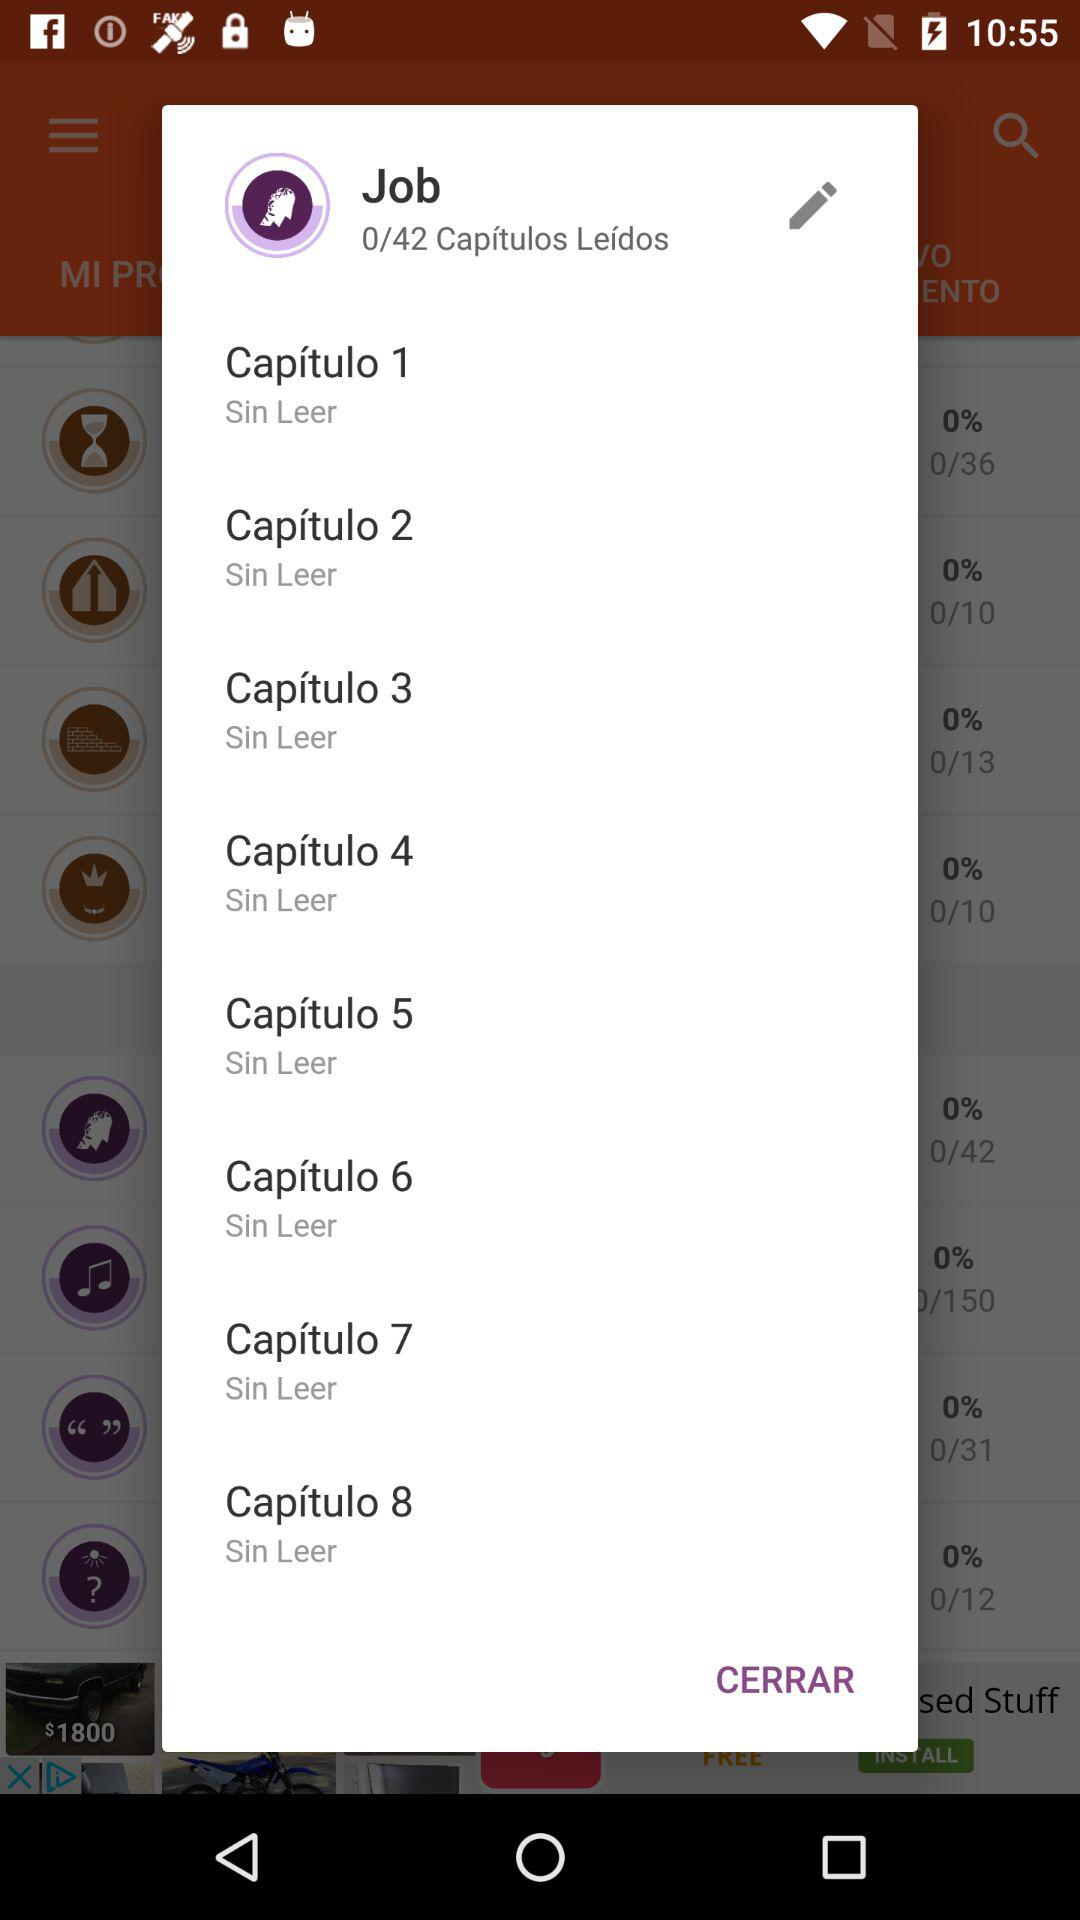How many chapters are in total?
Answer the question using a single word or phrase. 42 